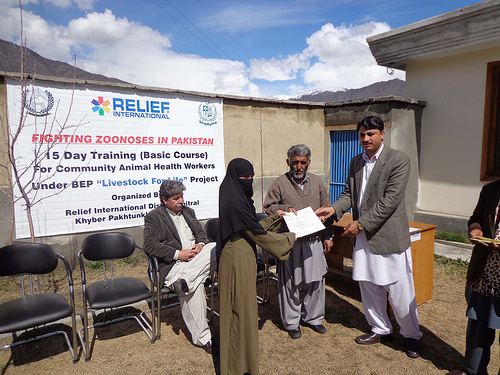<image>
Is the women to the right of the man? Yes. From this viewpoint, the women is positioned to the right side relative to the man. 